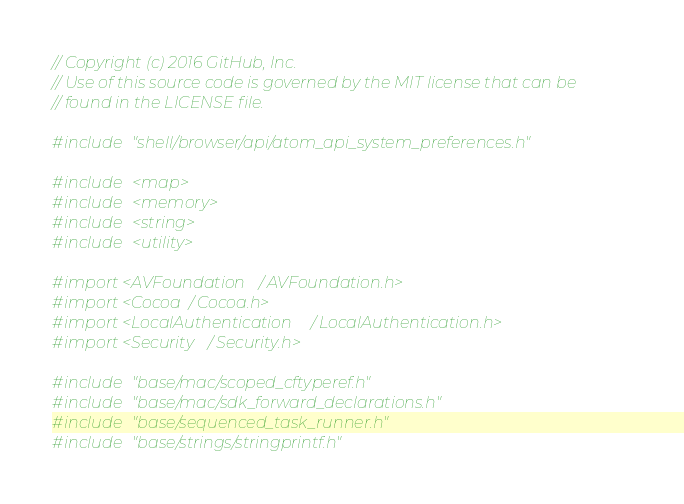<code> <loc_0><loc_0><loc_500><loc_500><_ObjectiveC_>// Copyright (c) 2016 GitHub, Inc.
// Use of this source code is governed by the MIT license that can be
// found in the LICENSE file.

#include "shell/browser/api/atom_api_system_preferences.h"

#include <map>
#include <memory>
#include <string>
#include <utility>

#import <AVFoundation/AVFoundation.h>
#import <Cocoa/Cocoa.h>
#import <LocalAuthentication/LocalAuthentication.h>
#import <Security/Security.h>

#include "base/mac/scoped_cftyperef.h"
#include "base/mac/sdk_forward_declarations.h"
#include "base/sequenced_task_runner.h"
#include "base/strings/stringprintf.h"</code> 